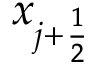<formula> <loc_0><loc_0><loc_500><loc_500>x _ { j + \frac { 1 } { 2 } }</formula> 